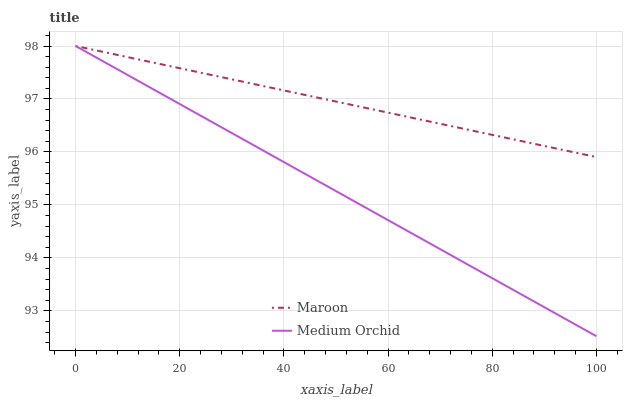Does Medium Orchid have the minimum area under the curve?
Answer yes or no. Yes. Does Maroon have the maximum area under the curve?
Answer yes or no. Yes. Does Maroon have the minimum area under the curve?
Answer yes or no. No. Is Medium Orchid the smoothest?
Answer yes or no. Yes. Is Maroon the roughest?
Answer yes or no. Yes. Is Maroon the smoothest?
Answer yes or no. No. Does Medium Orchid have the lowest value?
Answer yes or no. Yes. Does Maroon have the lowest value?
Answer yes or no. No. Does Maroon have the highest value?
Answer yes or no. Yes. Does Maroon intersect Medium Orchid?
Answer yes or no. Yes. Is Maroon less than Medium Orchid?
Answer yes or no. No. Is Maroon greater than Medium Orchid?
Answer yes or no. No. 